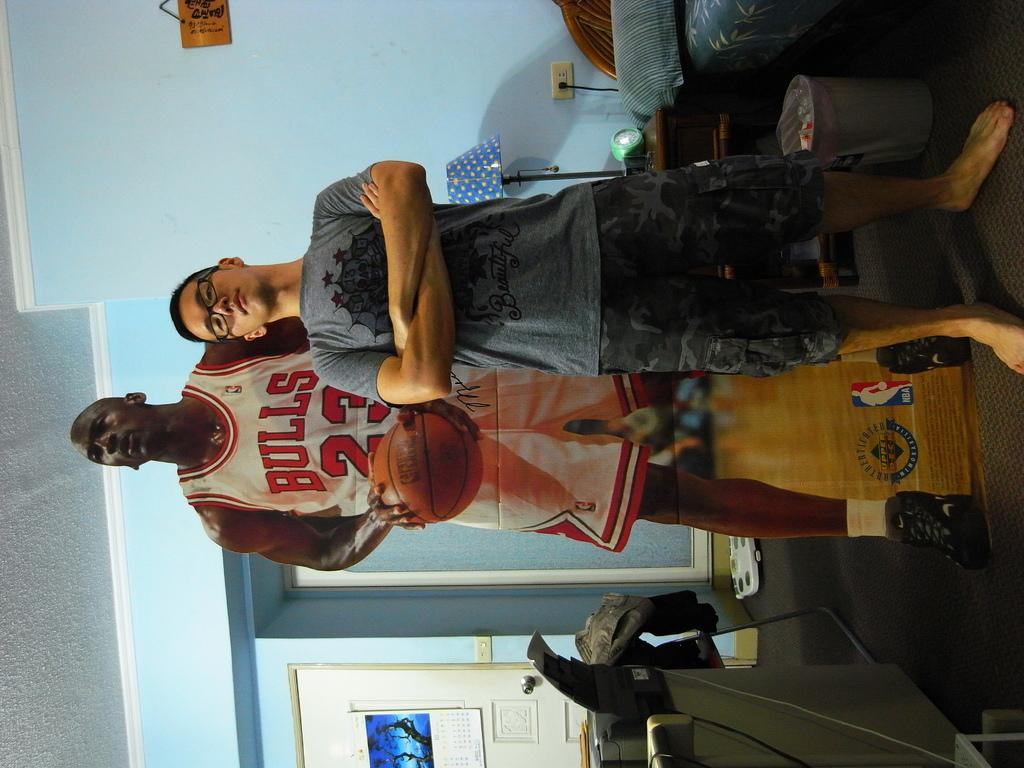<image>
Write a terse but informative summary of the picture. A man stands in front of a replica of Michael Jordan, a famous basketball player for the Chicago Bulls. 